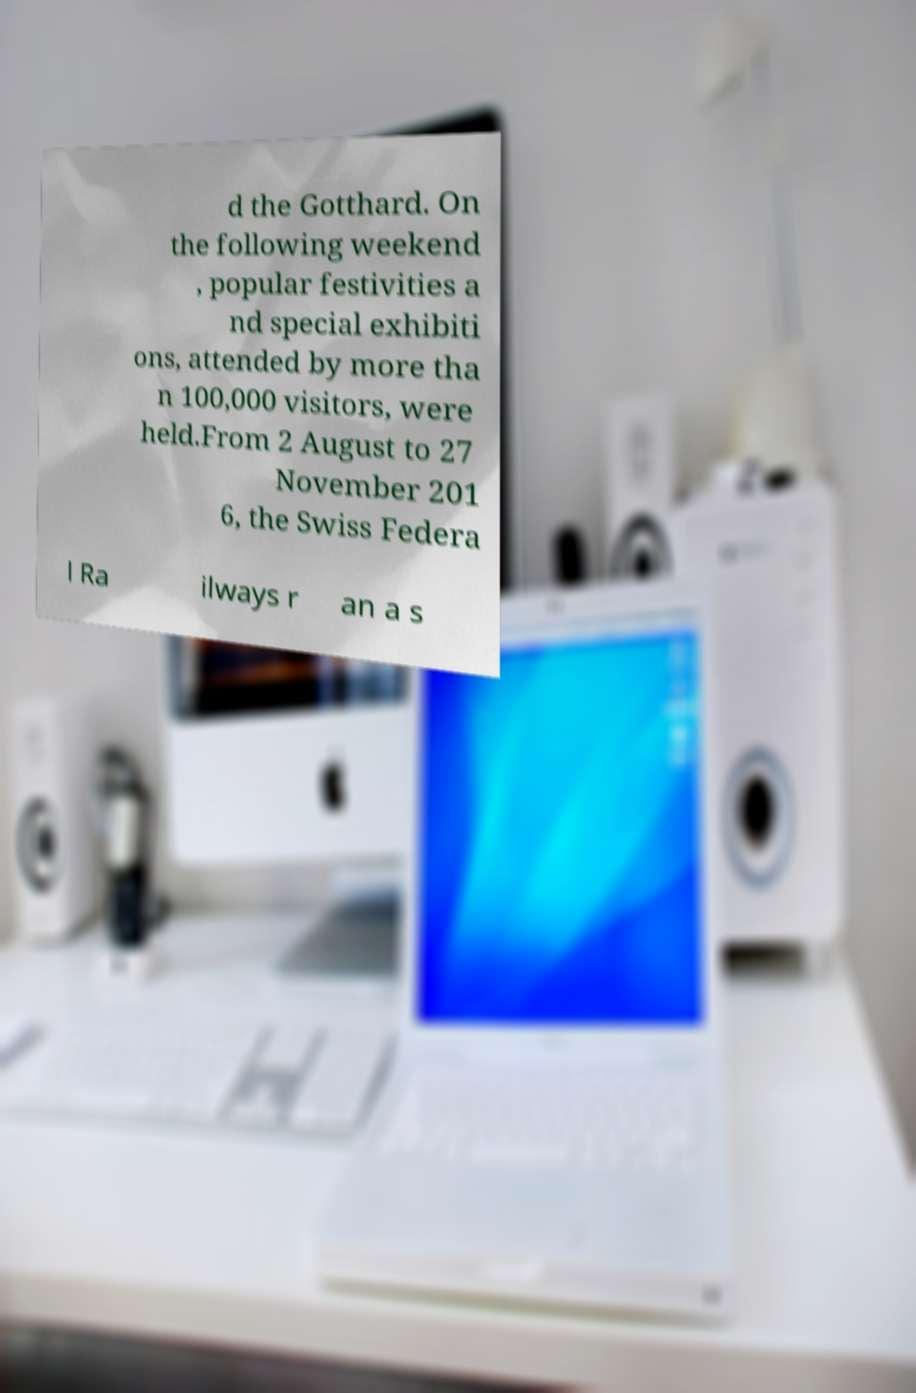Could you extract and type out the text from this image? d the Gotthard. On the following weekend , popular festivities a nd special exhibiti ons, attended by more tha n 100,000 visitors, were held.From 2 August to 27 November 201 6, the Swiss Federa l Ra ilways r an a s 